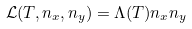<formula> <loc_0><loc_0><loc_500><loc_500>\mathcal { L } ( T , n _ { x } , n _ { y } ) = \Lambda ( T ) n _ { x } n _ { y }</formula> 